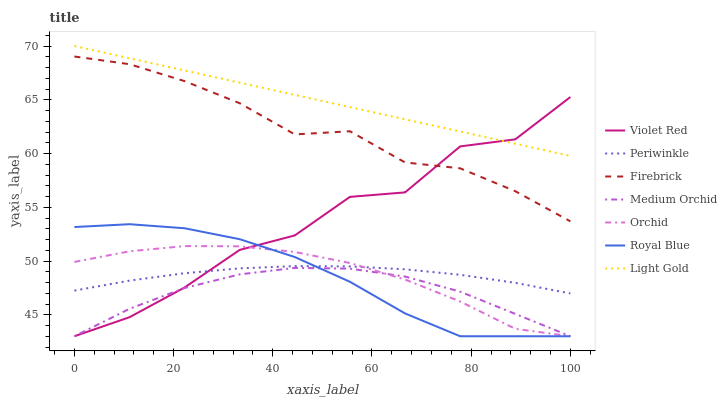Does Medium Orchid have the minimum area under the curve?
Answer yes or no. Yes. Does Light Gold have the maximum area under the curve?
Answer yes or no. Yes. Does Firebrick have the minimum area under the curve?
Answer yes or no. No. Does Firebrick have the maximum area under the curve?
Answer yes or no. No. Is Light Gold the smoothest?
Answer yes or no. Yes. Is Violet Red the roughest?
Answer yes or no. Yes. Is Firebrick the smoothest?
Answer yes or no. No. Is Firebrick the roughest?
Answer yes or no. No. Does Firebrick have the lowest value?
Answer yes or no. No. Does Light Gold have the highest value?
Answer yes or no. Yes. Does Firebrick have the highest value?
Answer yes or no. No. Is Medium Orchid less than Periwinkle?
Answer yes or no. Yes. Is Light Gold greater than Periwinkle?
Answer yes or no. Yes. Does Orchid intersect Periwinkle?
Answer yes or no. Yes. Is Orchid less than Periwinkle?
Answer yes or no. No. Is Orchid greater than Periwinkle?
Answer yes or no. No. Does Medium Orchid intersect Periwinkle?
Answer yes or no. No. 